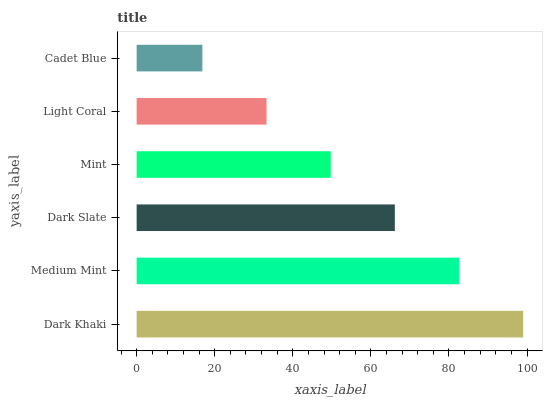Is Cadet Blue the minimum?
Answer yes or no. Yes. Is Dark Khaki the maximum?
Answer yes or no. Yes. Is Medium Mint the minimum?
Answer yes or no. No. Is Medium Mint the maximum?
Answer yes or no. No. Is Dark Khaki greater than Medium Mint?
Answer yes or no. Yes. Is Medium Mint less than Dark Khaki?
Answer yes or no. Yes. Is Medium Mint greater than Dark Khaki?
Answer yes or no. No. Is Dark Khaki less than Medium Mint?
Answer yes or no. No. Is Dark Slate the high median?
Answer yes or no. Yes. Is Mint the low median?
Answer yes or no. Yes. Is Mint the high median?
Answer yes or no. No. Is Dark Khaki the low median?
Answer yes or no. No. 